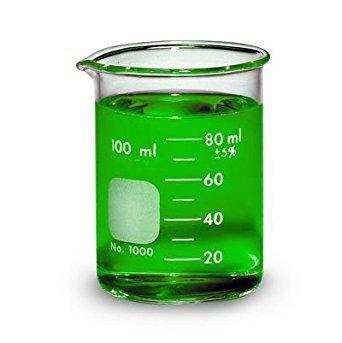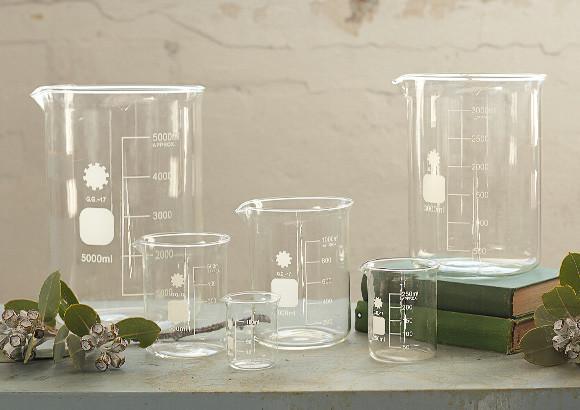The first image is the image on the left, the second image is the image on the right. Given the left and right images, does the statement "One of the liquids is green." hold true? Answer yes or no. Yes. The first image is the image on the left, the second image is the image on the right. Given the left and right images, does the statement "There is only one beaker in one of the images, and it has some liquid inside it." hold true? Answer yes or no. Yes. 